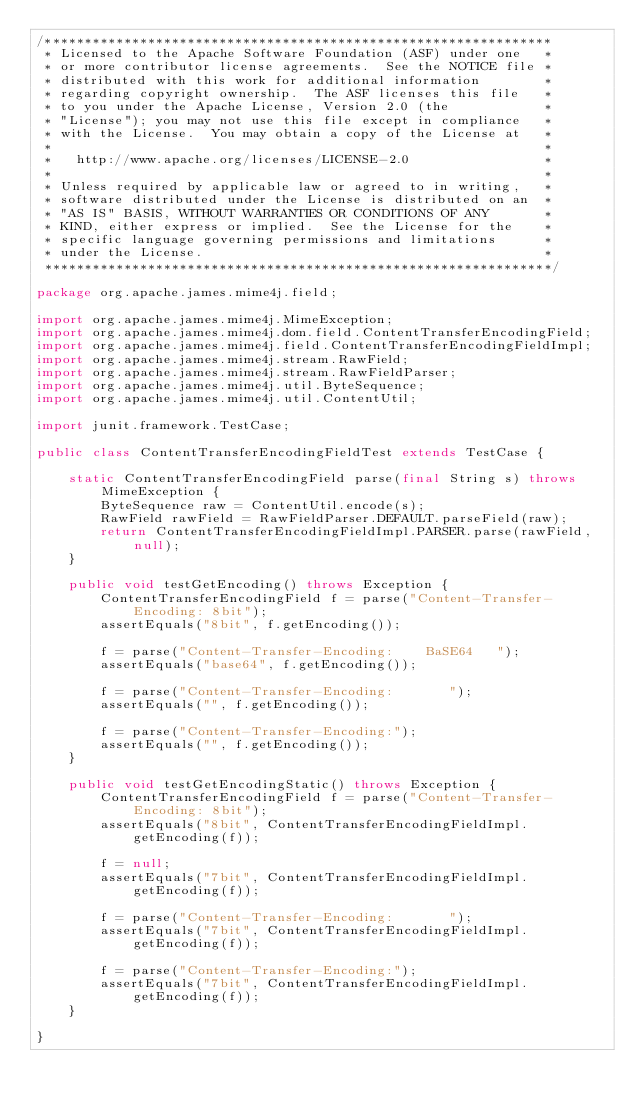<code> <loc_0><loc_0><loc_500><loc_500><_Java_>/****************************************************************
 * Licensed to the Apache Software Foundation (ASF) under one   *
 * or more contributor license agreements.  See the NOTICE file *
 * distributed with this work for additional information        *
 * regarding copyright ownership.  The ASF licenses this file   *
 * to you under the Apache License, Version 2.0 (the            *
 * "License"); you may not use this file except in compliance   *
 * with the License.  You may obtain a copy of the License at   *
 *                                                              *
 *   http://www.apache.org/licenses/LICENSE-2.0                 *
 *                                                              *
 * Unless required by applicable law or agreed to in writing,   *
 * software distributed under the License is distributed on an  *
 * "AS IS" BASIS, WITHOUT WARRANTIES OR CONDITIONS OF ANY       *
 * KIND, either express or implied.  See the License for the    *
 * specific language governing permissions and limitations      *
 * under the License.                                           *
 ****************************************************************/

package org.apache.james.mime4j.field;

import org.apache.james.mime4j.MimeException;
import org.apache.james.mime4j.dom.field.ContentTransferEncodingField;
import org.apache.james.mime4j.field.ContentTransferEncodingFieldImpl;
import org.apache.james.mime4j.stream.RawField;
import org.apache.james.mime4j.stream.RawFieldParser;
import org.apache.james.mime4j.util.ByteSequence;
import org.apache.james.mime4j.util.ContentUtil;

import junit.framework.TestCase;

public class ContentTransferEncodingFieldTest extends TestCase {

    static ContentTransferEncodingField parse(final String s) throws MimeException {
        ByteSequence raw = ContentUtil.encode(s);
        RawField rawField = RawFieldParser.DEFAULT.parseField(raw);
        return ContentTransferEncodingFieldImpl.PARSER.parse(rawField, null);
    }

    public void testGetEncoding() throws Exception {
        ContentTransferEncodingField f = parse("Content-Transfer-Encoding: 8bit");
        assertEquals("8bit", f.getEncoding());

        f = parse("Content-Transfer-Encoding:    BaSE64   ");
        assertEquals("base64", f.getEncoding());

        f = parse("Content-Transfer-Encoding:       ");
        assertEquals("", f.getEncoding());

        f = parse("Content-Transfer-Encoding:");
        assertEquals("", f.getEncoding());
    }

    public void testGetEncodingStatic() throws Exception {
        ContentTransferEncodingField f = parse("Content-Transfer-Encoding: 8bit");
        assertEquals("8bit", ContentTransferEncodingFieldImpl.getEncoding(f));

        f = null;
        assertEquals("7bit", ContentTransferEncodingFieldImpl.getEncoding(f));

        f = parse("Content-Transfer-Encoding:       ");
        assertEquals("7bit", ContentTransferEncodingFieldImpl.getEncoding(f));

        f = parse("Content-Transfer-Encoding:");
        assertEquals("7bit", ContentTransferEncodingFieldImpl.getEncoding(f));
    }

}
</code> 